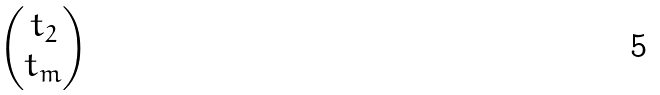<formula> <loc_0><loc_0><loc_500><loc_500>\begin{pmatrix} t _ { 2 } \\ t _ { m } \end{pmatrix}</formula> 